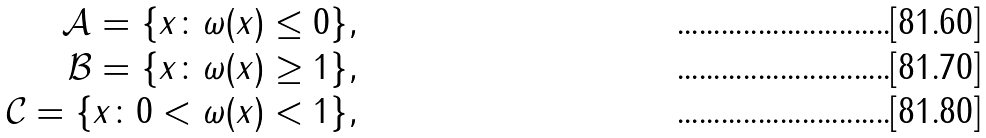<formula> <loc_0><loc_0><loc_500><loc_500>\mathcal { A } = \{ x \colon \omega ( x ) \leq 0 \} , \\ \mathcal { B } = \{ x \colon \omega ( x ) \geq 1 \} , \\ \mathcal { C } = \{ x \colon 0 < \omega ( x ) < 1 \} ,</formula> 